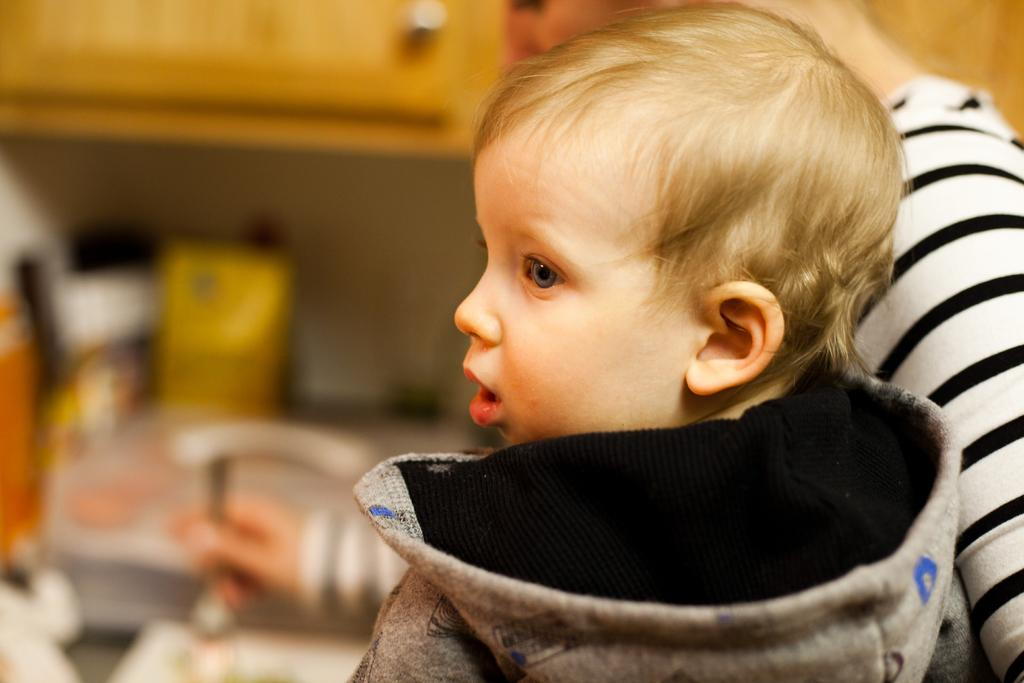Who is present in the image? There is a kid and a lady in the image. What can be seen in the background of the image? There is a cupboard and other objects visible in the background of the image. What verse can be heard being recited by the bird in the image? There is no bird present in the image, so no verse can be heard. 